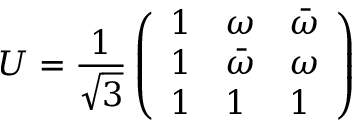Convert formula to latex. <formula><loc_0><loc_0><loc_500><loc_500>U = \frac { 1 } { \sqrt { 3 } } \left ( \begin{array} { l l l } { 1 } & { \omega } & { { \bar { \omega } } } \\ { 1 } & { { \bar { \omega } } } & { \omega } \\ { 1 } & { 1 } & { 1 } \end{array} \right )</formula> 